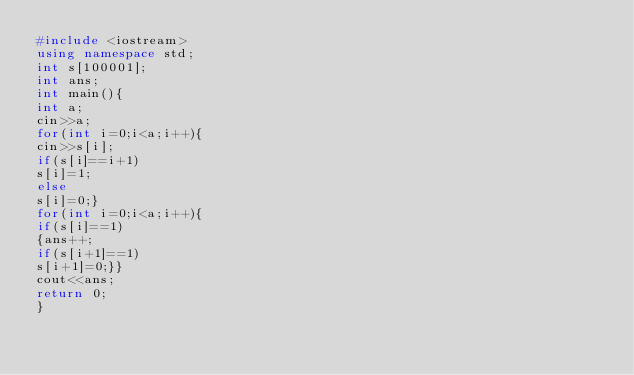<code> <loc_0><loc_0><loc_500><loc_500><_C++_>#include <iostream>
using namespace std;
int s[100001];
int ans;
int main(){
int a;
cin>>a;
for(int i=0;i<a;i++){
cin>>s[i];
if(s[i]==i+1)
s[i]=1;
else
s[i]=0;}
for(int i=0;i<a;i++){
if(s[i]==1)
{ans++;
if(s[i+1]==1)
s[i+1]=0;}}
cout<<ans;
return 0;
}</code> 